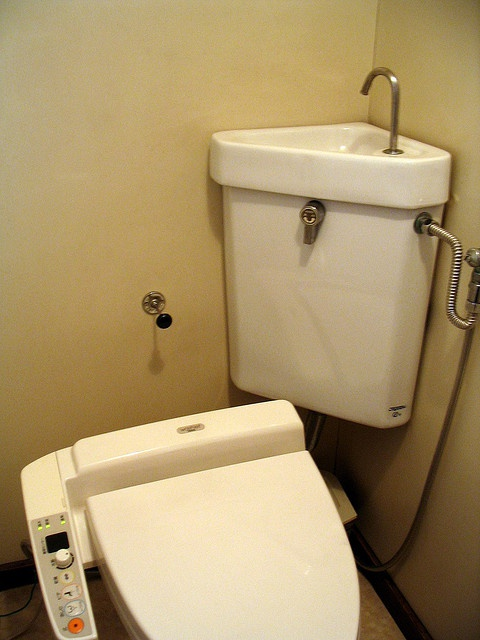Describe the objects in this image and their specific colors. I can see toilet in olive, beige, and tan tones and sink in olive, tan, and beige tones in this image. 